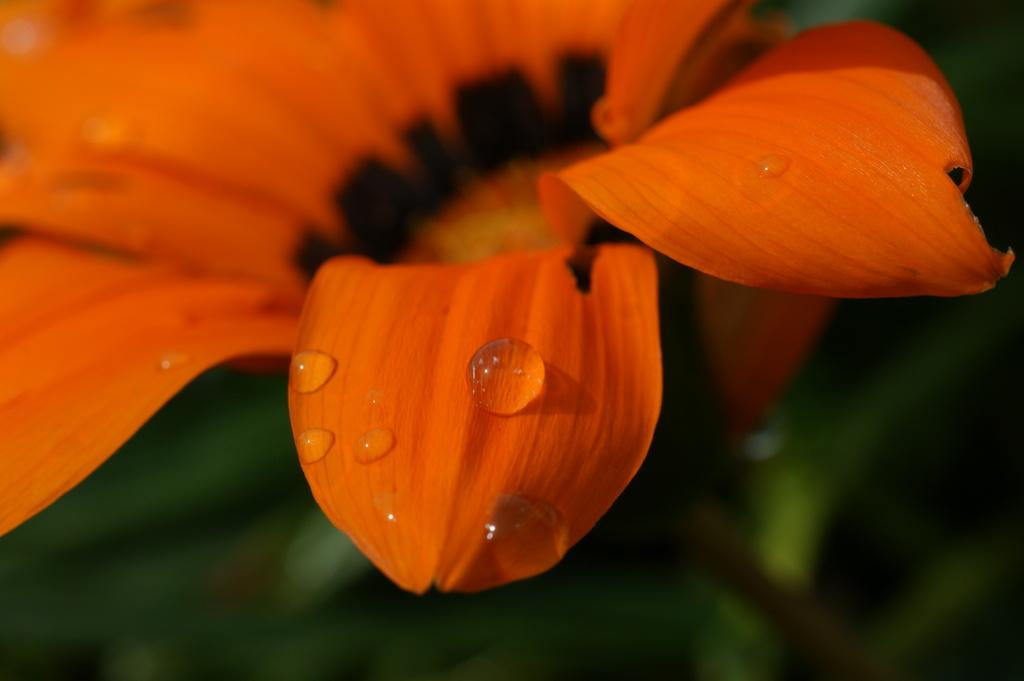What is the main subject of the image? The main subject of the image is a flower. What can be observed on the flower in the image? There are water droplets on the flower in the image. How many celery stalks are visible in the image? There are no celery stalks present in the image. What type of engine can be seen powering the flower in the image? There is no engine present in the image, and the flower is not powered by any engine. 